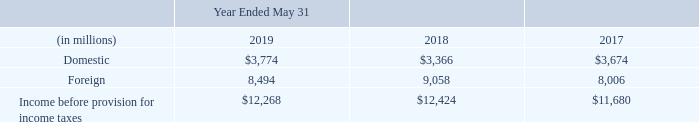14. INCOME TAXES
Our effective tax rates for each of the periods presented are the result of the mix of income earned in various tax jurisdictions that apply a broad range of income tax rates. The more significant provisions of the Tax Act as applicable to us are described in Note 1 above under “Impacts of the U.S. Tax Cuts and Jobs Act of 2017.” During fiscal 2019, we recorded a net benefit of $389 million in accordance with SAB 118 related to adjustments in our estimates of the one-time transition tax on certain foreign subsidiary earnings, and the remeasurement of our net deferred tax assets and liabilities affected by the Tax Act. Our provision for income taxes for fiscal 2019 varied from the 21% U.S. statutory rate imposed by the Tax Act primarily due to earnings in foreign operations, state taxes, the U.S. research and development tax credit, settlements with tax authorities, the tax effects of stock-based compensation, the Foreign Derived Intangible Income deduction, the tax effect of GILTI, and a reduction to our transition tax recorded consistent with the provision of SAB 118. Our provision for income taxes for fiscal 2018 varied from the 21% U.S. statutory rate imposed by the Tax Act primarily due to the impacts of the Tax Act upon adoption, state taxes, the U.S. research and development tax credit, settlements with tax authorities, the tax effects of stock-based compensation and the U.S. domestic production activity deduction. Prior to the January 1, 2018 effective date of the Tax Act, our provision for income taxes historically differed from the tax computed at the previous U.S. federal statutory income tax rate due primarily to certain earnings considered as indefinitely reinvested in foreign operations, state taxes, the U.S. research and development tax cr edit, settlements with tax authorities, the tax effects of stock-based compensation and the U.S. domestic production activity deduction.
The following is a geographical breakdown of income before the provision for income taxes:
Why did the company's provision for income taxes for fiscal 2019 vary from the 21% U.S. statutory rate imposed by the Tax Act? Our provision for income taxes for fiscal 2019 varied from the 21% u.s. statutory rate imposed by the tax act primarily due to earnings in foreign operations, state taxes, the u.s. research and development tax credit, settlements with tax authorities, the tax effects of stock-based compensation, the foreign derived intangible income deduction, the tax effect of gilti, and a reduction to our transition tax recorded consistent with the provision of sab 118. Why did the company's provision for income taxes for fiscal 2018 vary from the 21% U.S. statutory rate imposed by the Tax Act? Our provision for income taxes for fiscal 2018 varied from the 21% u.s. statutory rate imposed by the tax act primarily due to the impacts of the tax act upon adoption, state taxes, the u.s. research and development tax credit, settlements with tax authorities, the tax effects of stock-based compensation and the u.s. domestic production activity deduction. What was the company's domestic income for fiscal year 2018?
Answer scale should be: million. $3,366. What was the average domestic income for the 3 year period from 2017 to 2019?
Answer scale should be: million. (3,774+3,366+3,674)/3
Answer: 3604.67. What was the average total income before provision of income taxes for the 3 year period from 2017 to 2019?
Answer scale should be: million. (12,268+12,424+11,680)/3
Answer: 12124. What is the % change in the foreign income from 2017 to 2018, in billions?
Answer scale should be: percent. (9,058-8,006)/8,006
Answer: 13.14. 